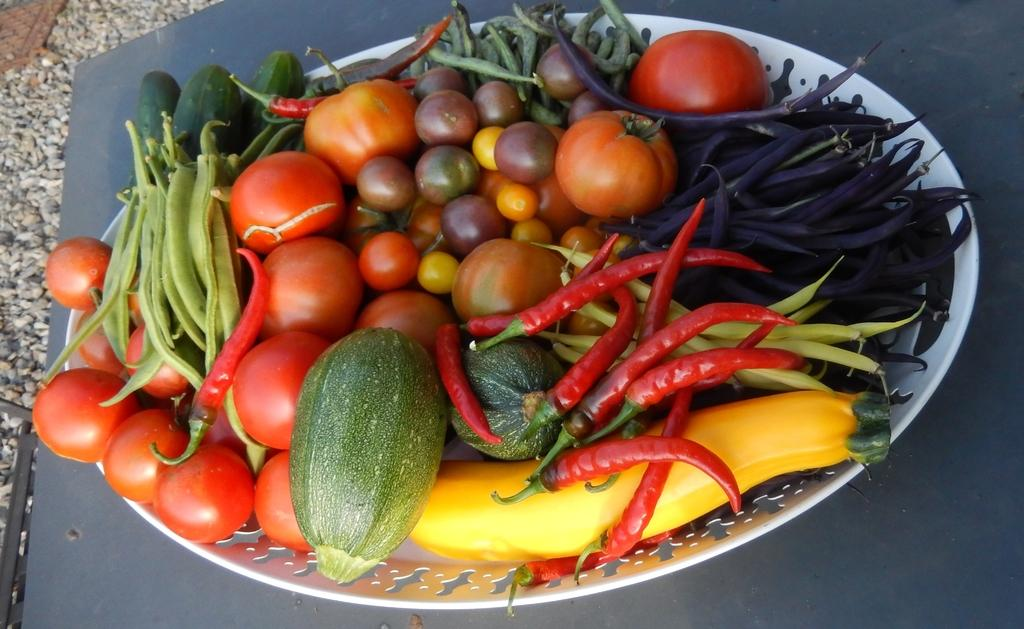What is on the plate that is visible in the image? The plate contains tomatoes, chilies, beans, and other vegetables. What type of surface is the plate placed on? The plate is placed on a surface, but the specific type of surface is not mentioned in the facts. Are there any other objects visible on the surface? The facts do not mention any other objects on the surface. What can be seen on the ground in the image? There are stones on the ground. What type of creature is driving the car in the image? There is no car or creature present in the image; it features a plate with vegetables and stones on the ground. 